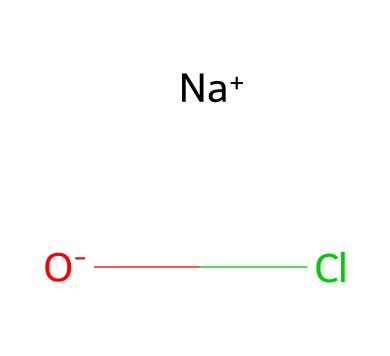What is the chemical name of the compound represented by this SMILES? The SMILES representation shows sodium (Na) and chloride (Cl) bonded to a negatively charged oxygen atom (O-), indicating that this is sodium hypochlorite.
Answer: sodium hypochlorite How many atoms are in the chemical structure? The two distinct ions represented are sodium (1), oxygen (1), and chlorine (1), totaling three atoms in the structure.
Answer: three What type of ion is sodium in this compound? Sodium is represented as [Na+], indicating that it is a cation (positively charged ion) in the chemical structure.
Answer: cation Which element in this compound acts as the oxidizing agent? Chlorine, represented in the structure, is typically the element that undergoes reduction, thus acting as the oxidizing agent in sodium hypochlorite.
Answer: chlorine How many bonds are suggested by the given SMILES structure? The structure involves one bond between the oxygen and chlorine and an ionic interaction between sodium and the hypochlorite ion, indicating that there are at least two significant interactions present.
Answer: two What oxidation state does chlorine have in sodium hypochlorite? In sodium hypochlorite, chlorine has a +1 oxidation state, which can be deduced from the overall charge balance of the compound combined with sodium's +1 charge.
Answer: +1 What is the primary use of sodium hypochlorite in relation to tennis courts? Sodium hypochlorite is used primarily for sanitizing and disinfecting surfaces, which is crucial for maintaining cleanliness on tennis courts.
Answer: disinfecting 